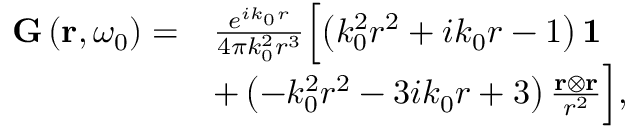Convert formula to latex. <formula><loc_0><loc_0><loc_500><loc_500>\begin{array} { r l } { G \left ( r , \omega _ { 0 } \right ) = } & { \frac { e ^ { i k _ { 0 } r } } { 4 \pi k _ { 0 } ^ { 2 } r ^ { 3 } } \left [ \left ( k _ { 0 } ^ { 2 } r ^ { 2 } + i k _ { 0 } r - 1 \right ) 1 } \\ & { + \left ( - k _ { 0 } ^ { 2 } r ^ { 2 } - 3 i k _ { 0 } r + 3 \right ) \frac { r \otimes r } { r ^ { 2 } } \right ] , } \end{array}</formula> 